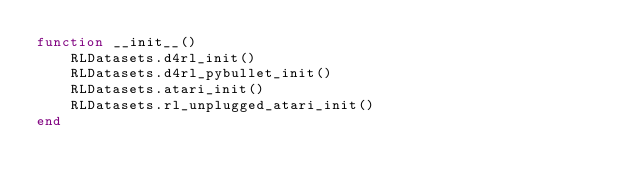Convert code to text. <code><loc_0><loc_0><loc_500><loc_500><_Julia_>function __init__()
    RLDatasets.d4rl_init()
    RLDatasets.d4rl_pybullet_init()
    RLDatasets.atari_init()
    RLDatasets.rl_unplugged_atari_init()
end</code> 